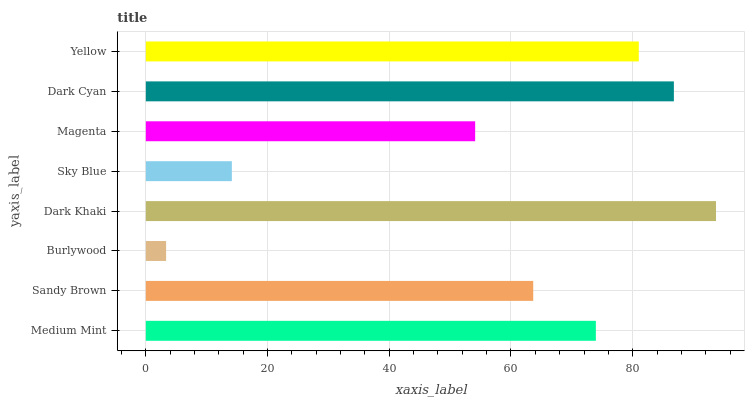Is Burlywood the minimum?
Answer yes or no. Yes. Is Dark Khaki the maximum?
Answer yes or no. Yes. Is Sandy Brown the minimum?
Answer yes or no. No. Is Sandy Brown the maximum?
Answer yes or no. No. Is Medium Mint greater than Sandy Brown?
Answer yes or no. Yes. Is Sandy Brown less than Medium Mint?
Answer yes or no. Yes. Is Sandy Brown greater than Medium Mint?
Answer yes or no. No. Is Medium Mint less than Sandy Brown?
Answer yes or no. No. Is Medium Mint the high median?
Answer yes or no. Yes. Is Sandy Brown the low median?
Answer yes or no. Yes. Is Sandy Brown the high median?
Answer yes or no. No. Is Dark Cyan the low median?
Answer yes or no. No. 